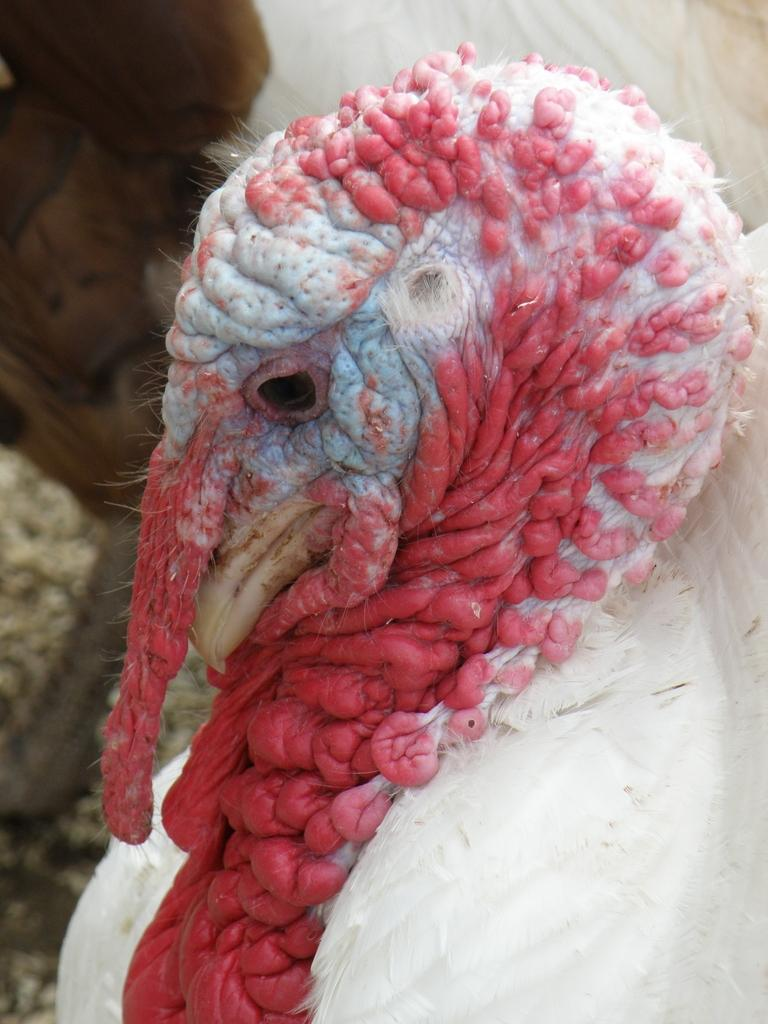What type of animal is present in the image? There is a white-colored domestic turkey in the image. What type of books can be seen in the image? There are no books or a library present in the image; it features a white-colored domestic turkey. What type of hair is visible on the turkey in the image? Turkeys do not have hair; they have feathers. The image shows a white-colored domestic turkey with feathers. 